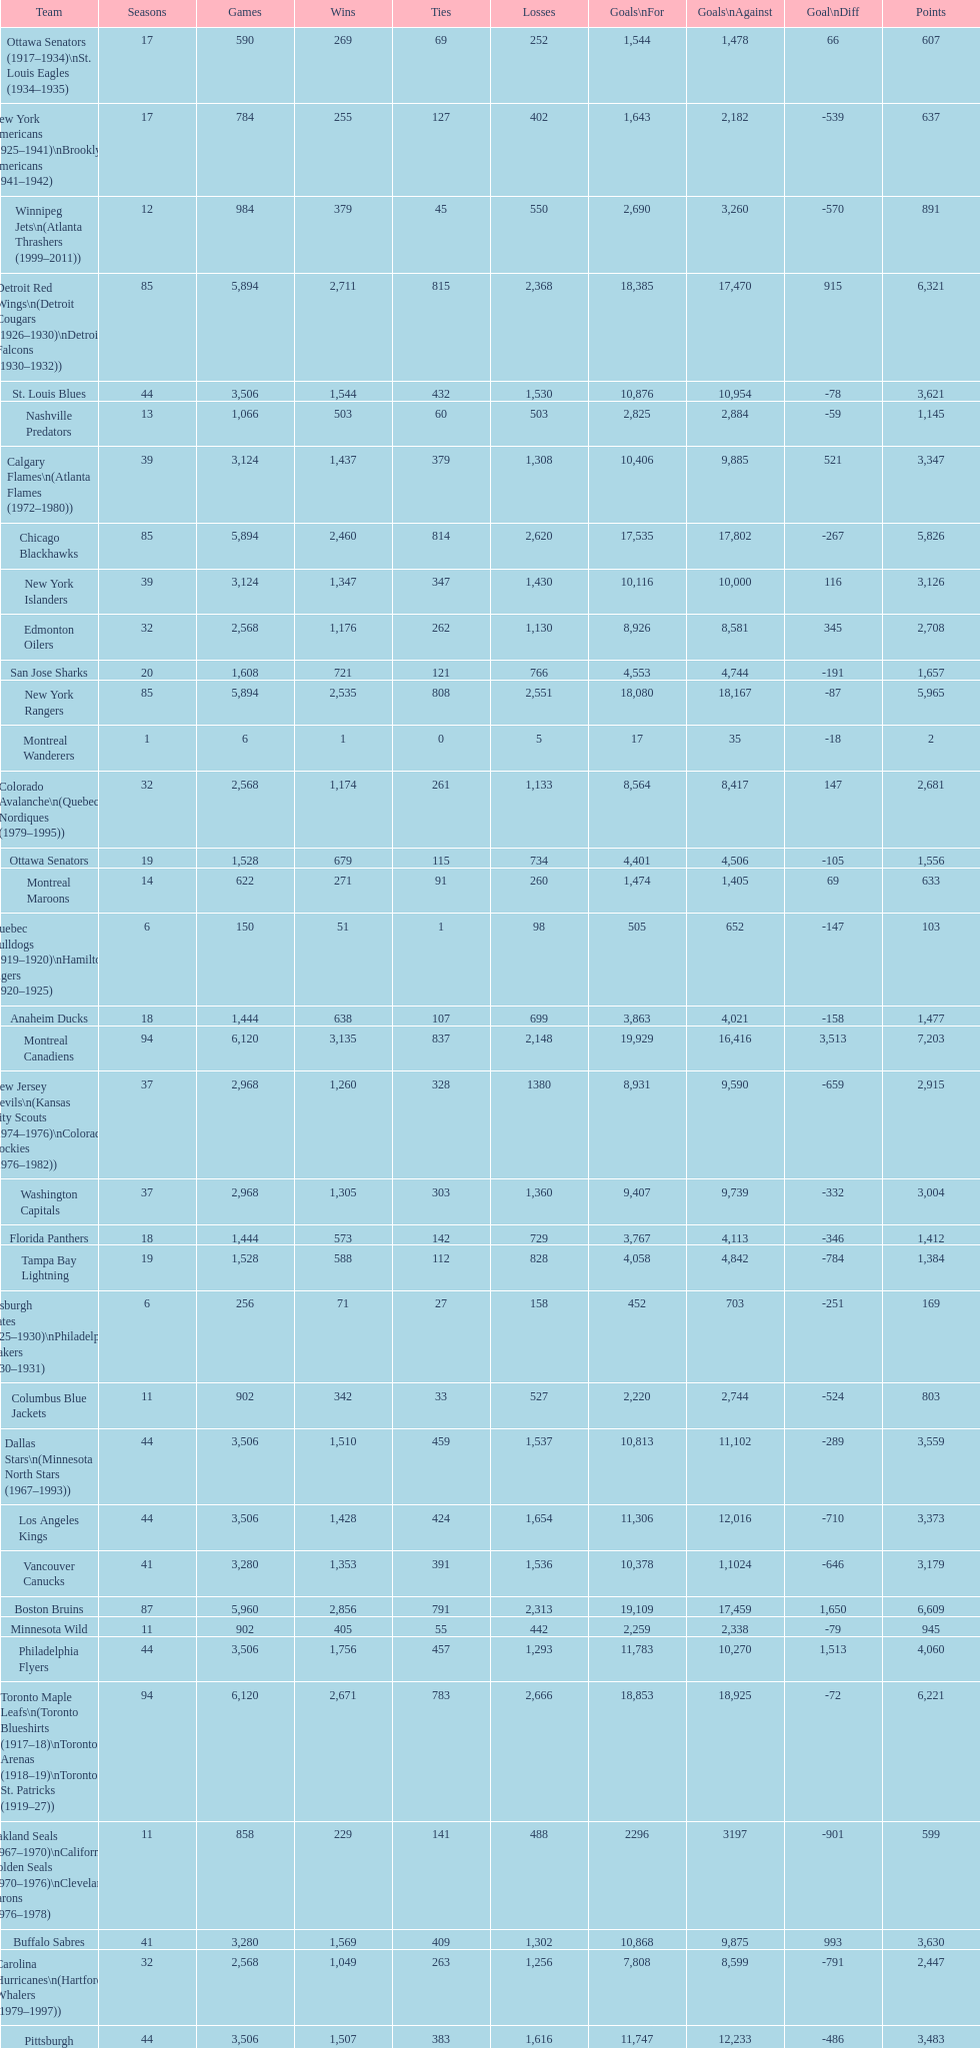Which team played the same amount of seasons as the canadiens? Toronto Maple Leafs. 